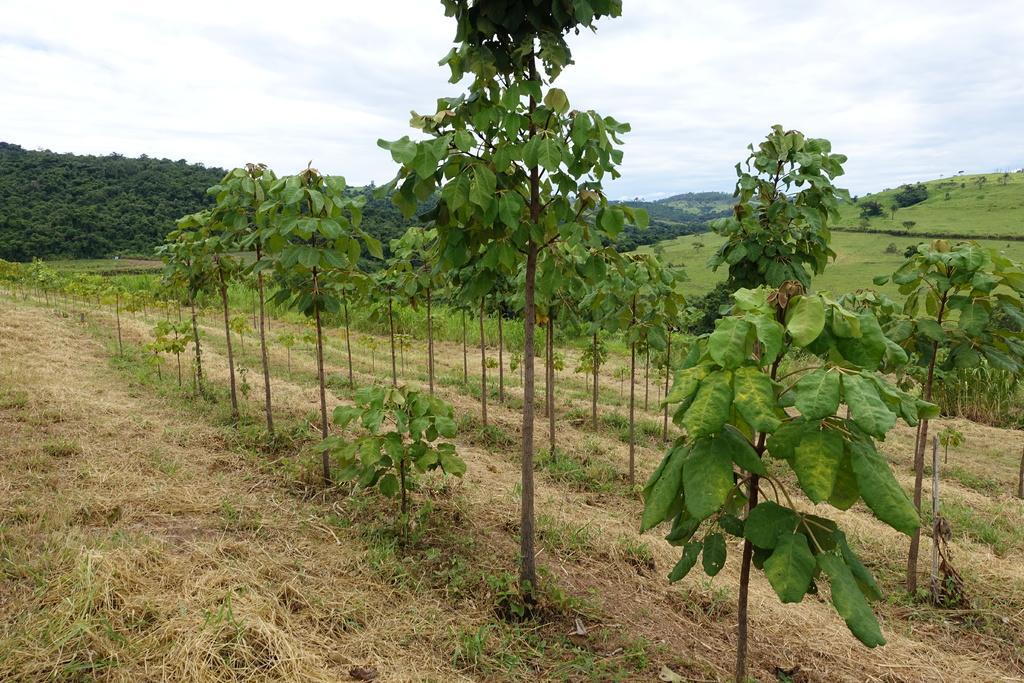How would you summarize this image in a sentence or two? In this picture I can see many plants and grass. In the background I can see the trees, mountains and farmland. At the top I can see the sky and clouds. In the bottom right I can see many leaves. 